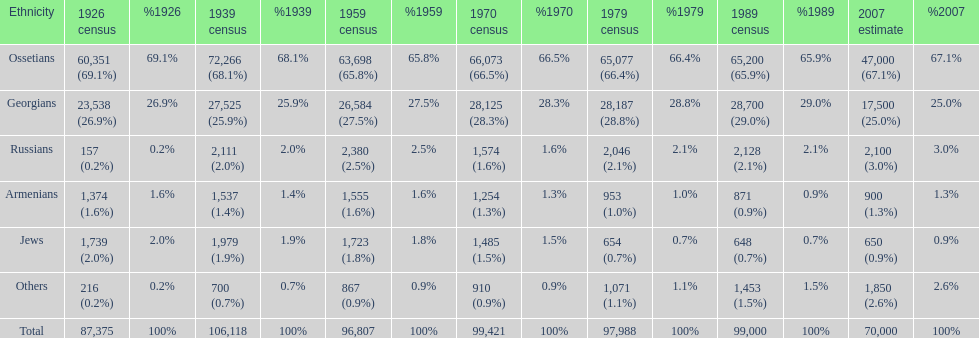What ethnicity is at the top? Ossetians. 